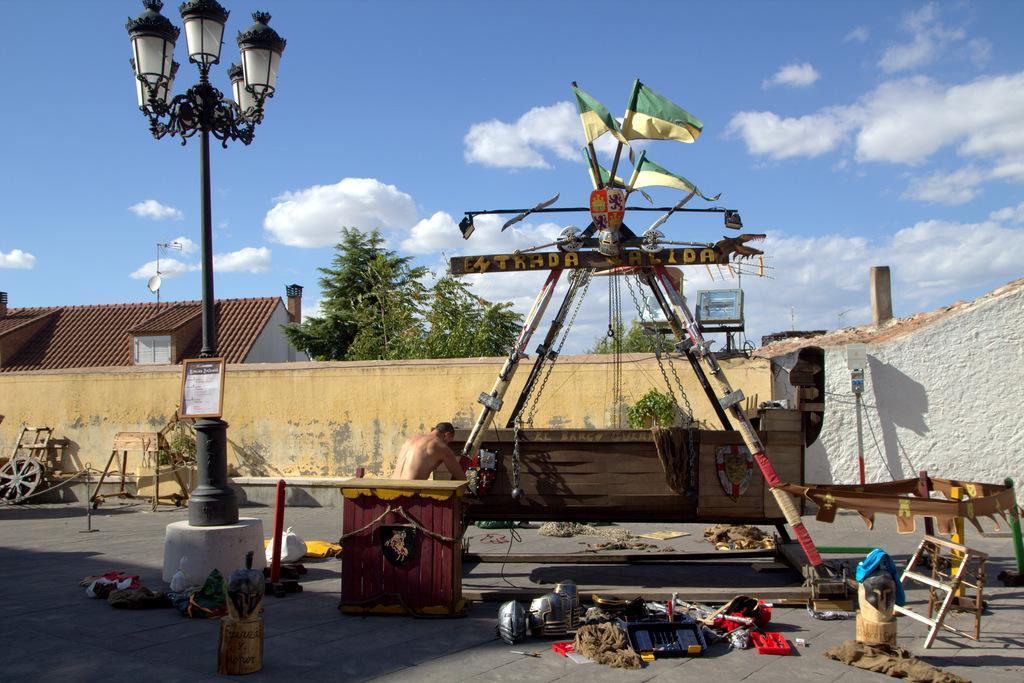Describe this image in one or two sentences. In this picture we can see a person, poles, flags, wheel, walls, house, trees and some objects and in the background we can see the sky with clouds. 